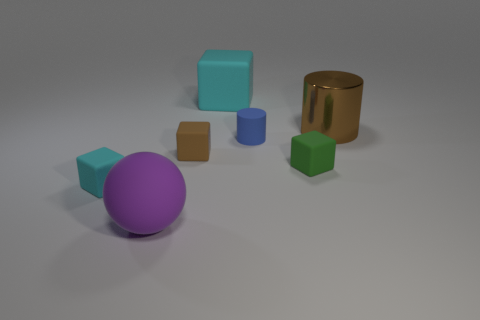The blue object that is the same material as the brown cube is what shape? cylinder 